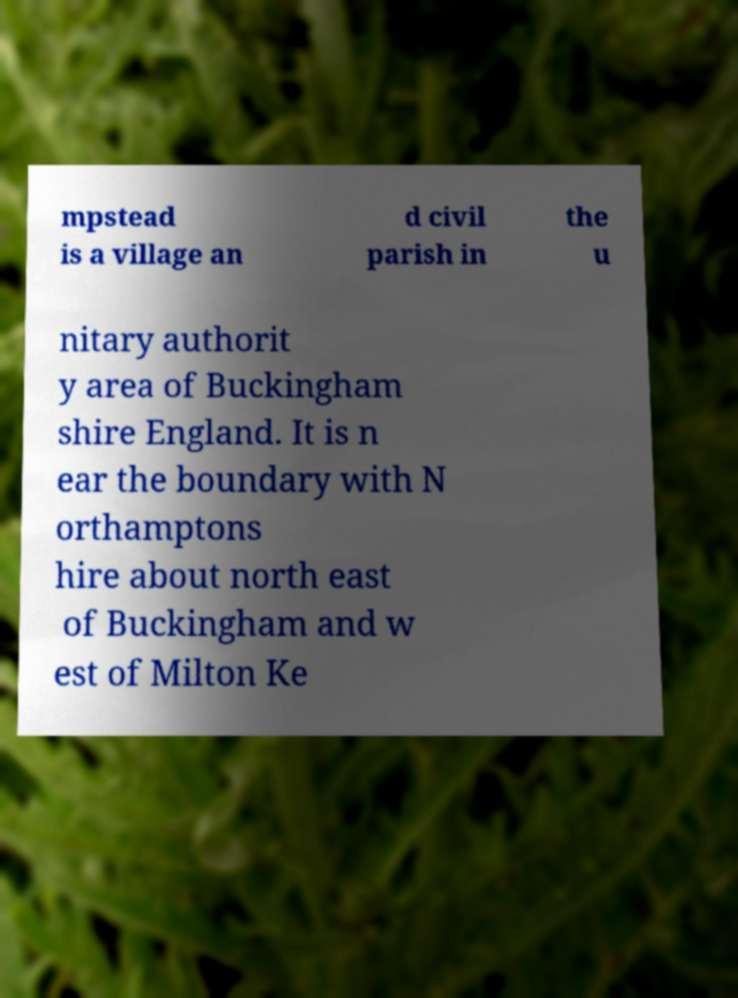Can you accurately transcribe the text from the provided image for me? mpstead is a village an d civil parish in the u nitary authorit y area of Buckingham shire England. It is n ear the boundary with N orthamptons hire about north east of Buckingham and w est of Milton Ke 